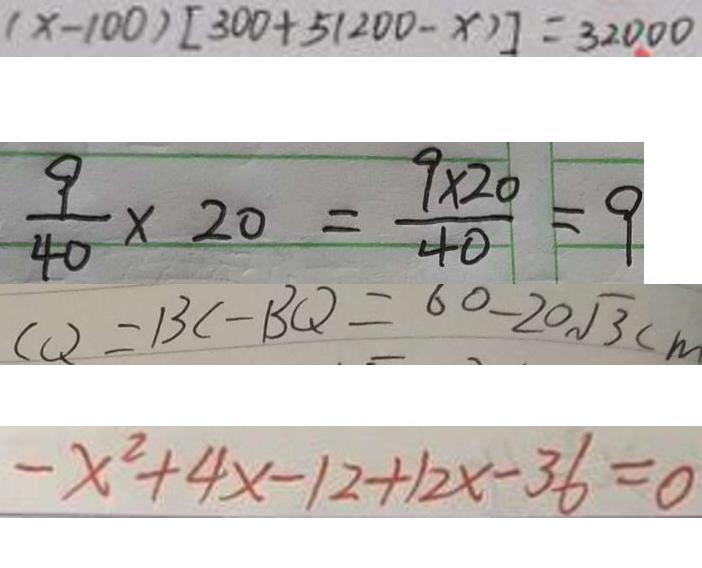Convert formula to latex. <formula><loc_0><loc_0><loc_500><loc_500>( x - 1 0 0 ) [ 3 0 0 + 5 ( 2 0 0 - x ) ] = 3 2 0 0 0 
 \frac { 9 } { 4 0 } \times 2 0 = \frac { 9 \times 2 0 } { 4 0 } = 9 
 C Q = B C - B Q = 6 0 - 2 0 \sqrt { 3 } c m 
 - x ^ { 2 } + 4 x - 1 2 + 1 2 x - 3 6 = 0</formula> 